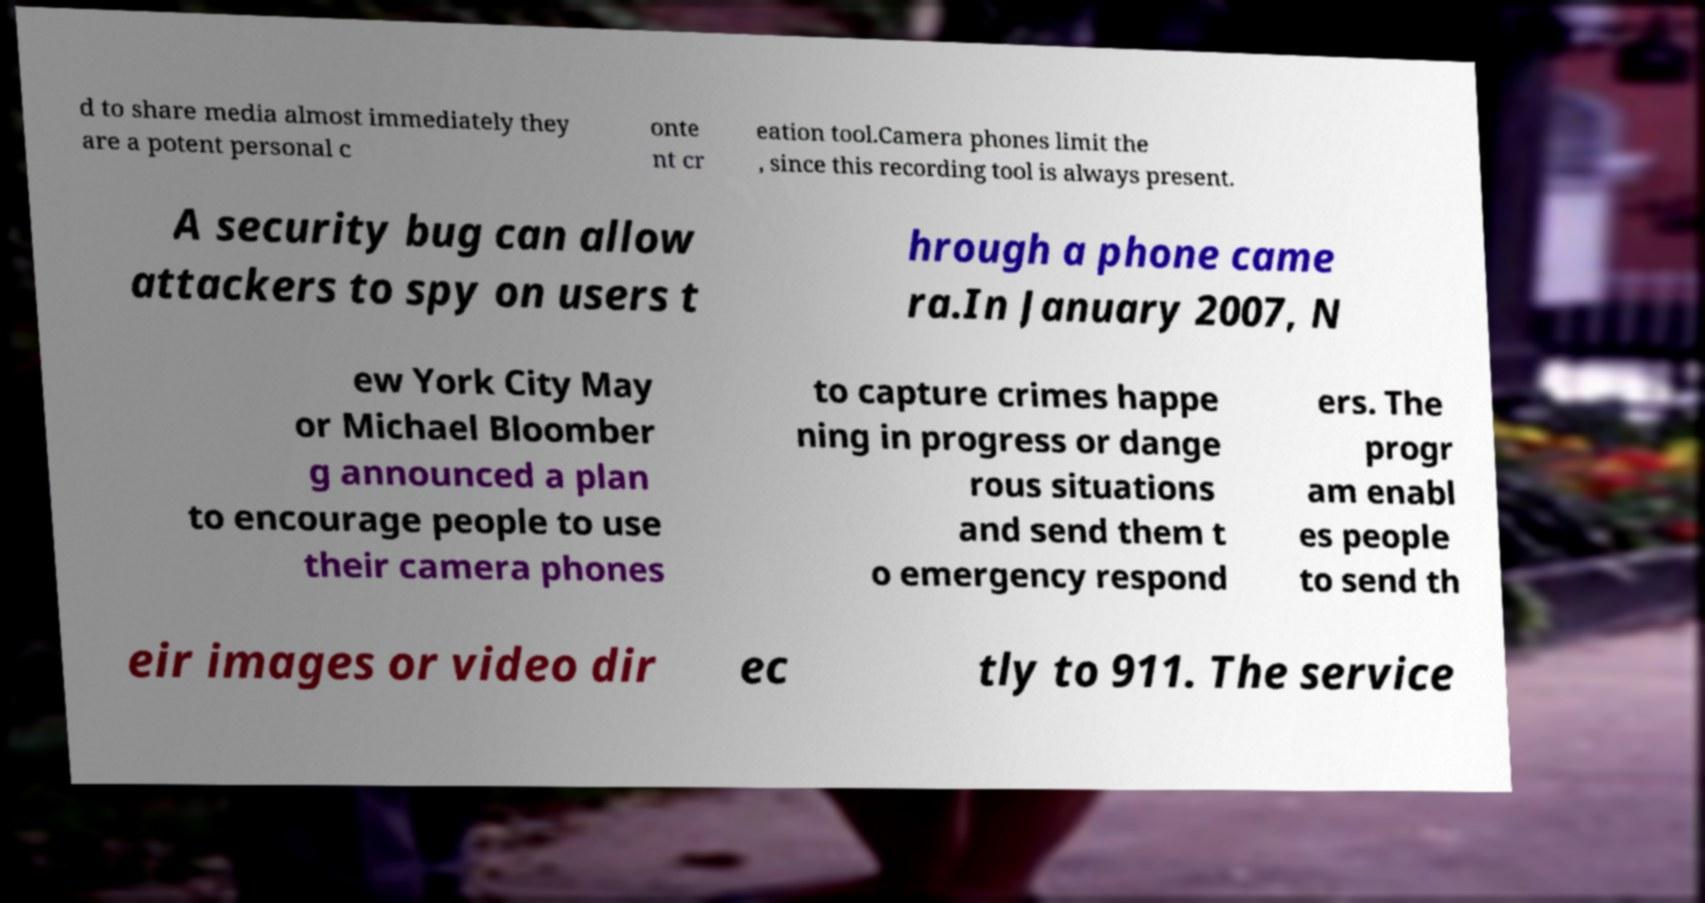What messages or text are displayed in this image? I need them in a readable, typed format. d to share media almost immediately they are a potent personal c onte nt cr eation tool.Camera phones limit the , since this recording tool is always present. A security bug can allow attackers to spy on users t hrough a phone came ra.In January 2007, N ew York City May or Michael Bloomber g announced a plan to encourage people to use their camera phones to capture crimes happe ning in progress or dange rous situations and send them t o emergency respond ers. The progr am enabl es people to send th eir images or video dir ec tly to 911. The service 